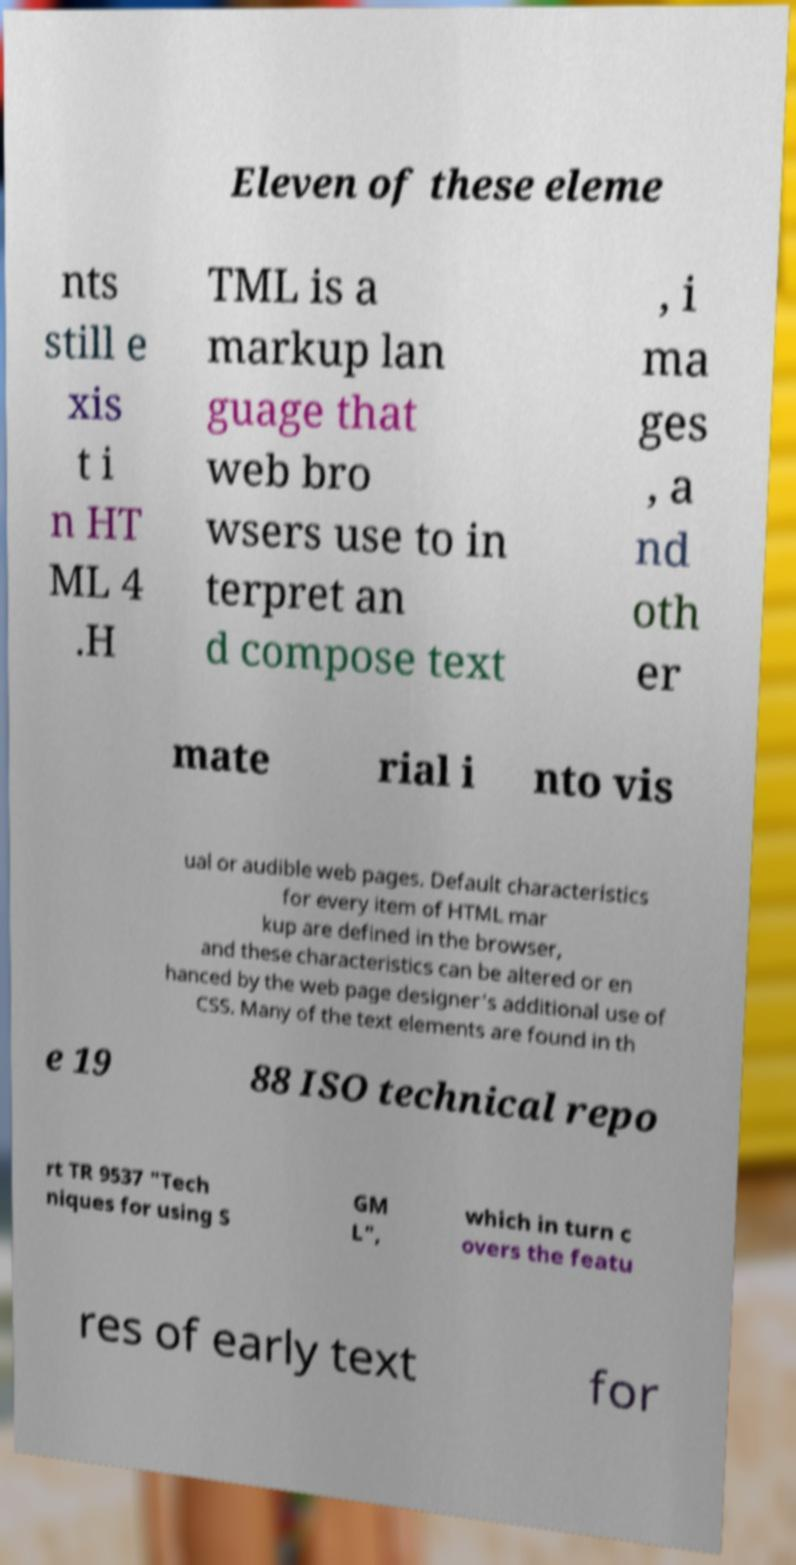I need the written content from this picture converted into text. Can you do that? Eleven of these eleme nts still e xis t i n HT ML 4 .H TML is a markup lan guage that web bro wsers use to in terpret an d compose text , i ma ges , a nd oth er mate rial i nto vis ual or audible web pages. Default characteristics for every item of HTML mar kup are defined in the browser, and these characteristics can be altered or en hanced by the web page designer's additional use of CSS. Many of the text elements are found in th e 19 88 ISO technical repo rt TR 9537 "Tech niques for using S GM L", which in turn c overs the featu res of early text for 